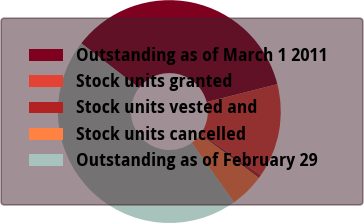<chart> <loc_0><loc_0><loc_500><loc_500><pie_chart><fcel>Outstanding as of March 1 2011<fcel>Stock units granted<fcel>Stock units vested and<fcel>Stock units cancelled<fcel>Outstanding as of February 29<nl><fcel>35.55%<fcel>13.62%<fcel>0.5%<fcel>4.98%<fcel>45.35%<nl></chart> 